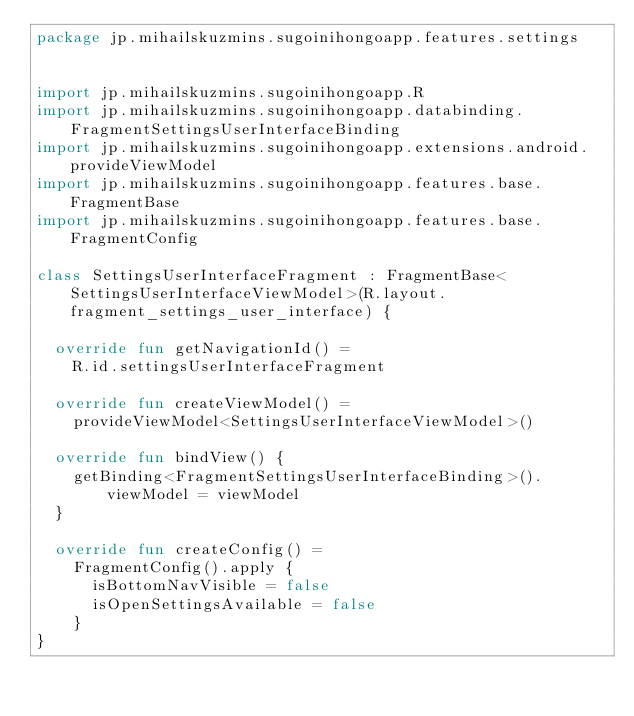Convert code to text. <code><loc_0><loc_0><loc_500><loc_500><_Kotlin_>package jp.mihailskuzmins.sugoinihongoapp.features.settings


import jp.mihailskuzmins.sugoinihongoapp.R
import jp.mihailskuzmins.sugoinihongoapp.databinding.FragmentSettingsUserInterfaceBinding
import jp.mihailskuzmins.sugoinihongoapp.extensions.android.provideViewModel
import jp.mihailskuzmins.sugoinihongoapp.features.base.FragmentBase
import jp.mihailskuzmins.sugoinihongoapp.features.base.FragmentConfig

class SettingsUserInterfaceFragment : FragmentBase<SettingsUserInterfaceViewModel>(R.layout.fragment_settings_user_interface) {

	override fun getNavigationId() =
		R.id.settingsUserInterfaceFragment

	override fun createViewModel() =
		provideViewModel<SettingsUserInterfaceViewModel>()

	override fun bindView() {
		getBinding<FragmentSettingsUserInterfaceBinding>().viewModel = viewModel
	}

	override fun createConfig() =
		FragmentConfig().apply {
			isBottomNavVisible = false
			isOpenSettingsAvailable = false
		}
}
</code> 